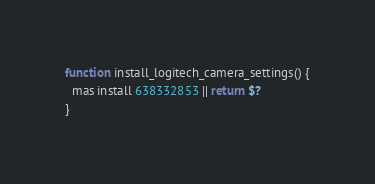Convert code to text. <code><loc_0><loc_0><loc_500><loc_500><_Bash_>function install_logitech_camera_settings() {
  mas install 638332853 || return $?
}
</code> 